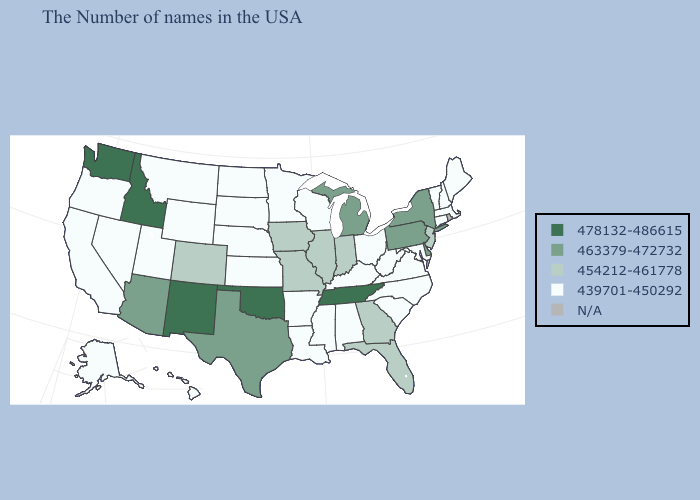What is the value of Arkansas?
Give a very brief answer. 439701-450292. What is the value of Montana?
Give a very brief answer. 439701-450292. Does Idaho have the lowest value in the West?
Keep it brief. No. Among the states that border New Mexico , which have the lowest value?
Keep it brief. Utah. Does New Mexico have the highest value in the USA?
Write a very short answer. Yes. What is the value of Maine?
Be succinct. 439701-450292. Name the states that have a value in the range 463379-472732?
Write a very short answer. New York, Delaware, Pennsylvania, Michigan, Texas, Arizona. What is the value of Iowa?
Short answer required. 454212-461778. Among the states that border Florida , which have the lowest value?
Be succinct. Alabama. Name the states that have a value in the range 478132-486615?
Keep it brief. Tennessee, Oklahoma, New Mexico, Idaho, Washington. Name the states that have a value in the range 478132-486615?
Write a very short answer. Tennessee, Oklahoma, New Mexico, Idaho, Washington. Which states hav the highest value in the South?
Short answer required. Tennessee, Oklahoma. Name the states that have a value in the range 454212-461778?
Be succinct. New Jersey, Florida, Georgia, Indiana, Illinois, Missouri, Iowa, Colorado. 